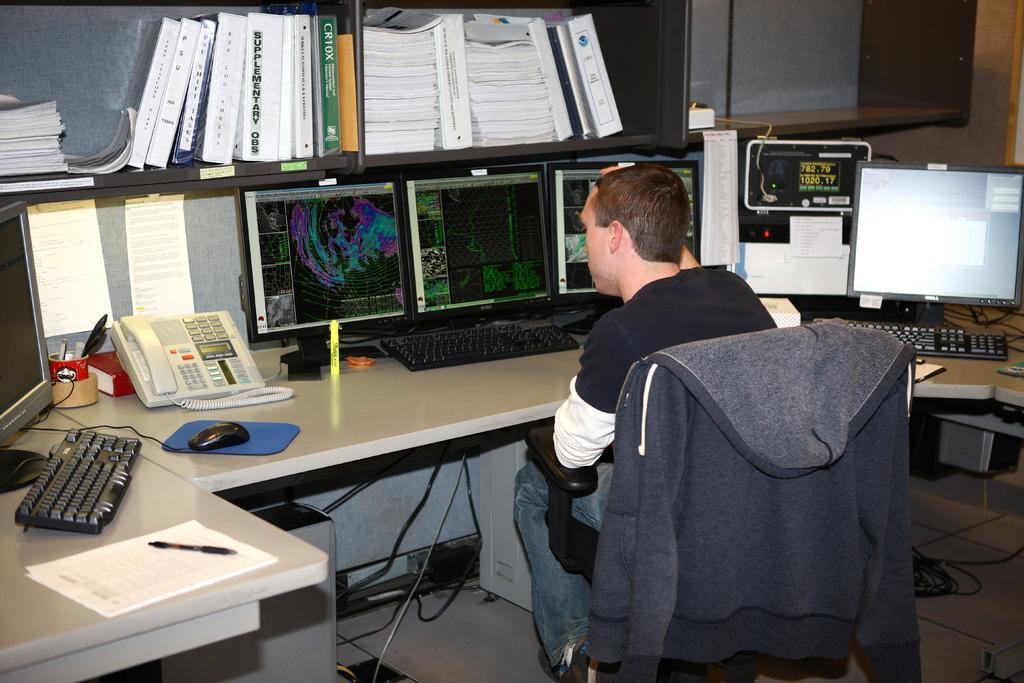Please provide a concise description of this image. Here is a man sitting on the chair. This is a jerkin which is put on the chair. This is the table with a telephone,pen stand,mouse with a mouse pad,monitors,keyboard,papers,pen placed on the table. This looks like a bookshelf with some books placed inside it. 